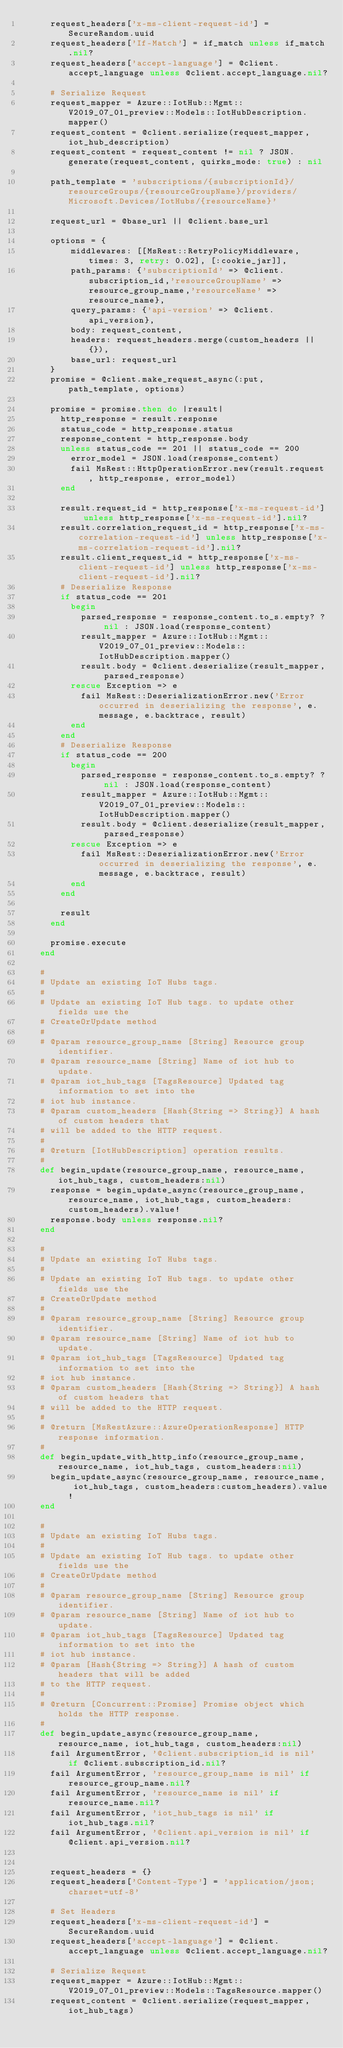<code> <loc_0><loc_0><loc_500><loc_500><_Ruby_>      request_headers['x-ms-client-request-id'] = SecureRandom.uuid
      request_headers['If-Match'] = if_match unless if_match.nil?
      request_headers['accept-language'] = @client.accept_language unless @client.accept_language.nil?

      # Serialize Request
      request_mapper = Azure::IotHub::Mgmt::V2019_07_01_preview::Models::IotHubDescription.mapper()
      request_content = @client.serialize(request_mapper,  iot_hub_description)
      request_content = request_content != nil ? JSON.generate(request_content, quirks_mode: true) : nil

      path_template = 'subscriptions/{subscriptionId}/resourceGroups/{resourceGroupName}/providers/Microsoft.Devices/IotHubs/{resourceName}'

      request_url = @base_url || @client.base_url

      options = {
          middlewares: [[MsRest::RetryPolicyMiddleware, times: 3, retry: 0.02], [:cookie_jar]],
          path_params: {'subscriptionId' => @client.subscription_id,'resourceGroupName' => resource_group_name,'resourceName' => resource_name},
          query_params: {'api-version' => @client.api_version},
          body: request_content,
          headers: request_headers.merge(custom_headers || {}),
          base_url: request_url
      }
      promise = @client.make_request_async(:put, path_template, options)

      promise = promise.then do |result|
        http_response = result.response
        status_code = http_response.status
        response_content = http_response.body
        unless status_code == 201 || status_code == 200
          error_model = JSON.load(response_content)
          fail MsRest::HttpOperationError.new(result.request, http_response, error_model)
        end

        result.request_id = http_response['x-ms-request-id'] unless http_response['x-ms-request-id'].nil?
        result.correlation_request_id = http_response['x-ms-correlation-request-id'] unless http_response['x-ms-correlation-request-id'].nil?
        result.client_request_id = http_response['x-ms-client-request-id'] unless http_response['x-ms-client-request-id'].nil?
        # Deserialize Response
        if status_code == 201
          begin
            parsed_response = response_content.to_s.empty? ? nil : JSON.load(response_content)
            result_mapper = Azure::IotHub::Mgmt::V2019_07_01_preview::Models::IotHubDescription.mapper()
            result.body = @client.deserialize(result_mapper, parsed_response)
          rescue Exception => e
            fail MsRest::DeserializationError.new('Error occurred in deserializing the response', e.message, e.backtrace, result)
          end
        end
        # Deserialize Response
        if status_code == 200
          begin
            parsed_response = response_content.to_s.empty? ? nil : JSON.load(response_content)
            result_mapper = Azure::IotHub::Mgmt::V2019_07_01_preview::Models::IotHubDescription.mapper()
            result.body = @client.deserialize(result_mapper, parsed_response)
          rescue Exception => e
            fail MsRest::DeserializationError.new('Error occurred in deserializing the response', e.message, e.backtrace, result)
          end
        end

        result
      end

      promise.execute
    end

    #
    # Update an existing IoT Hubs tags.
    #
    # Update an existing IoT Hub tags. to update other fields use the
    # CreateOrUpdate method
    #
    # @param resource_group_name [String] Resource group identifier.
    # @param resource_name [String] Name of iot hub to update.
    # @param iot_hub_tags [TagsResource] Updated tag information to set into the
    # iot hub instance.
    # @param custom_headers [Hash{String => String}] A hash of custom headers that
    # will be added to the HTTP request.
    #
    # @return [IotHubDescription] operation results.
    #
    def begin_update(resource_group_name, resource_name, iot_hub_tags, custom_headers:nil)
      response = begin_update_async(resource_group_name, resource_name, iot_hub_tags, custom_headers:custom_headers).value!
      response.body unless response.nil?
    end

    #
    # Update an existing IoT Hubs tags.
    #
    # Update an existing IoT Hub tags. to update other fields use the
    # CreateOrUpdate method
    #
    # @param resource_group_name [String] Resource group identifier.
    # @param resource_name [String] Name of iot hub to update.
    # @param iot_hub_tags [TagsResource] Updated tag information to set into the
    # iot hub instance.
    # @param custom_headers [Hash{String => String}] A hash of custom headers that
    # will be added to the HTTP request.
    #
    # @return [MsRestAzure::AzureOperationResponse] HTTP response information.
    #
    def begin_update_with_http_info(resource_group_name, resource_name, iot_hub_tags, custom_headers:nil)
      begin_update_async(resource_group_name, resource_name, iot_hub_tags, custom_headers:custom_headers).value!
    end

    #
    # Update an existing IoT Hubs tags.
    #
    # Update an existing IoT Hub tags. to update other fields use the
    # CreateOrUpdate method
    #
    # @param resource_group_name [String] Resource group identifier.
    # @param resource_name [String] Name of iot hub to update.
    # @param iot_hub_tags [TagsResource] Updated tag information to set into the
    # iot hub instance.
    # @param [Hash{String => String}] A hash of custom headers that will be added
    # to the HTTP request.
    #
    # @return [Concurrent::Promise] Promise object which holds the HTTP response.
    #
    def begin_update_async(resource_group_name, resource_name, iot_hub_tags, custom_headers:nil)
      fail ArgumentError, '@client.subscription_id is nil' if @client.subscription_id.nil?
      fail ArgumentError, 'resource_group_name is nil' if resource_group_name.nil?
      fail ArgumentError, 'resource_name is nil' if resource_name.nil?
      fail ArgumentError, 'iot_hub_tags is nil' if iot_hub_tags.nil?
      fail ArgumentError, '@client.api_version is nil' if @client.api_version.nil?


      request_headers = {}
      request_headers['Content-Type'] = 'application/json; charset=utf-8'

      # Set Headers
      request_headers['x-ms-client-request-id'] = SecureRandom.uuid
      request_headers['accept-language'] = @client.accept_language unless @client.accept_language.nil?

      # Serialize Request
      request_mapper = Azure::IotHub::Mgmt::V2019_07_01_preview::Models::TagsResource.mapper()
      request_content = @client.serialize(request_mapper,  iot_hub_tags)</code> 